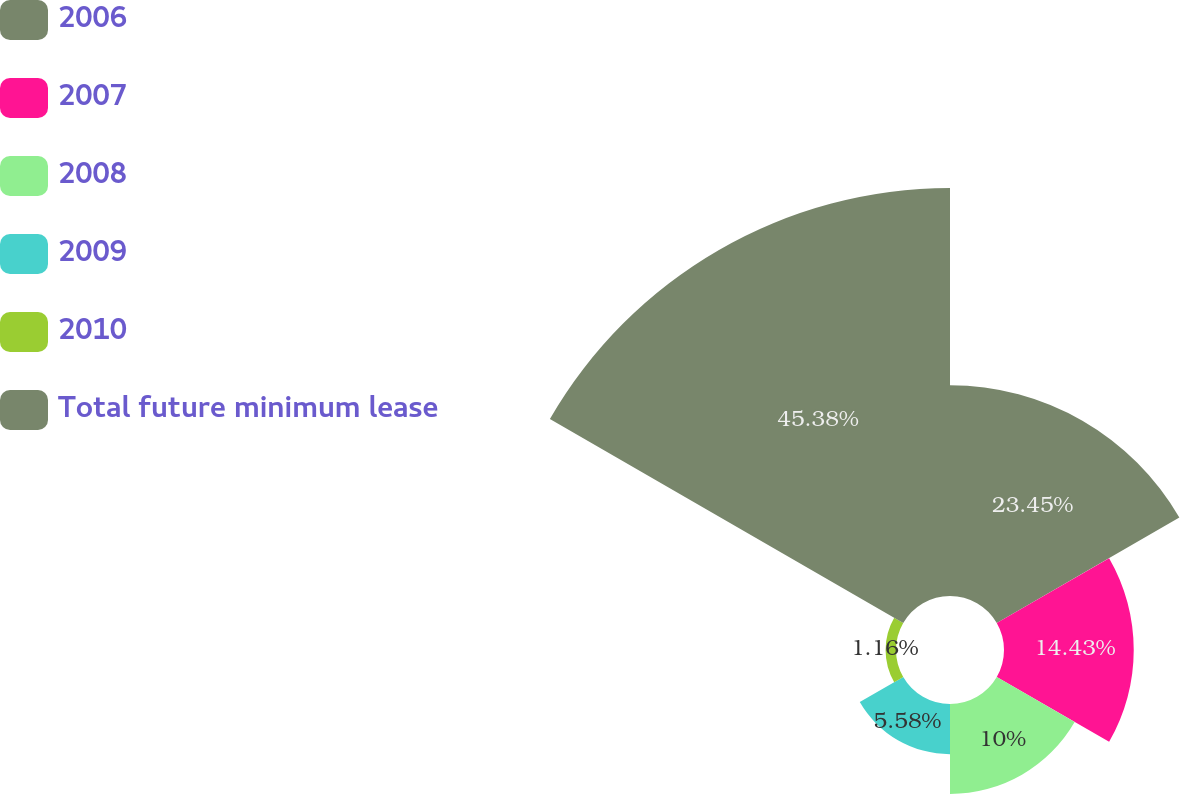Convert chart to OTSL. <chart><loc_0><loc_0><loc_500><loc_500><pie_chart><fcel>2006<fcel>2007<fcel>2008<fcel>2009<fcel>2010<fcel>Total future minimum lease<nl><fcel>23.45%<fcel>14.43%<fcel>10.0%<fcel>5.58%<fcel>1.16%<fcel>45.38%<nl></chart> 